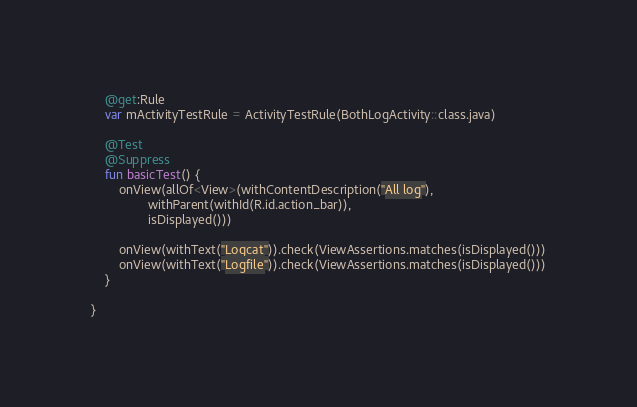Convert code to text. <code><loc_0><loc_0><loc_500><loc_500><_Kotlin_>    @get:Rule
    var mActivityTestRule = ActivityTestRule(BothLogActivity::class.java)

    @Test
    @Suppress
    fun basicTest() {
        onView(allOf<View>(withContentDescription("All log"),
                withParent(withId(R.id.action_bar)),
                isDisplayed()))

        onView(withText("Logcat")).check(ViewAssertions.matches(isDisplayed()))
        onView(withText("Logfile")).check(ViewAssertions.matches(isDisplayed()))
    }

}
</code> 